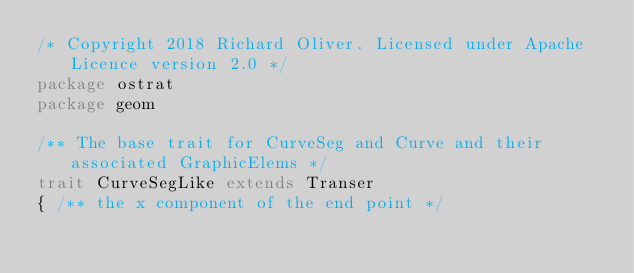<code> <loc_0><loc_0><loc_500><loc_500><_Scala_>/* Copyright 2018 Richard Oliver. Licensed under Apache Licence version 2.0 */
package ostrat
package geom

/** The base trait for CurveSeg and Curve and their associated GraphicElems */
trait CurveSegLike extends Transer
{ /** the x component of the end point */</code> 